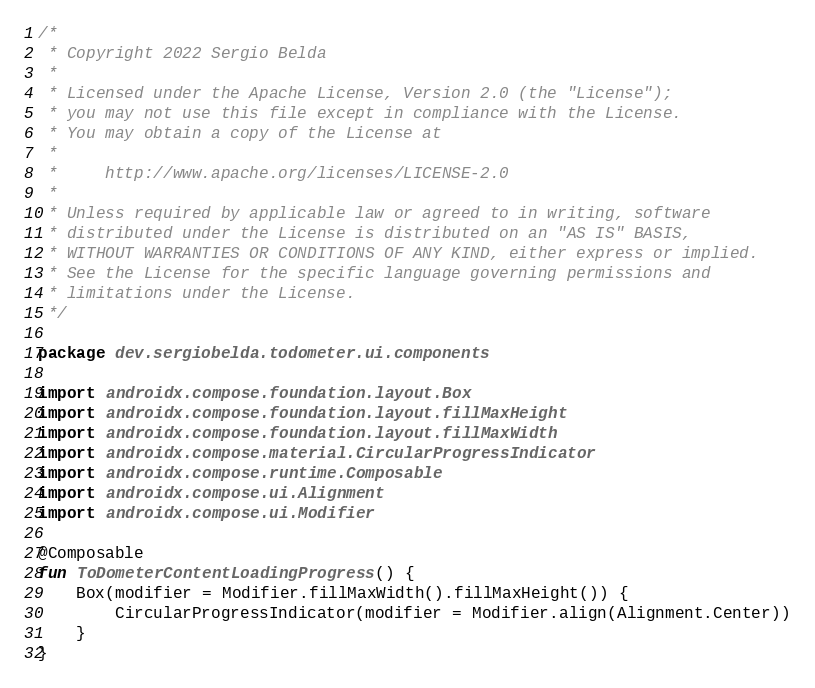Convert code to text. <code><loc_0><loc_0><loc_500><loc_500><_Kotlin_>/*
 * Copyright 2022 Sergio Belda
 *
 * Licensed under the Apache License, Version 2.0 (the "License");
 * you may not use this file except in compliance with the License.
 * You may obtain a copy of the License at
 *
 *     http://www.apache.org/licenses/LICENSE-2.0
 *
 * Unless required by applicable law or agreed to in writing, software
 * distributed under the License is distributed on an "AS IS" BASIS,
 * WITHOUT WARRANTIES OR CONDITIONS OF ANY KIND, either express or implied.
 * See the License for the specific language governing permissions and
 * limitations under the License.
 */

package dev.sergiobelda.todometer.ui.components

import androidx.compose.foundation.layout.Box
import androidx.compose.foundation.layout.fillMaxHeight
import androidx.compose.foundation.layout.fillMaxWidth
import androidx.compose.material.CircularProgressIndicator
import androidx.compose.runtime.Composable
import androidx.compose.ui.Alignment
import androidx.compose.ui.Modifier

@Composable
fun ToDometerContentLoadingProgress() {
    Box(modifier = Modifier.fillMaxWidth().fillMaxHeight()) {
        CircularProgressIndicator(modifier = Modifier.align(Alignment.Center))
    }
}
</code> 